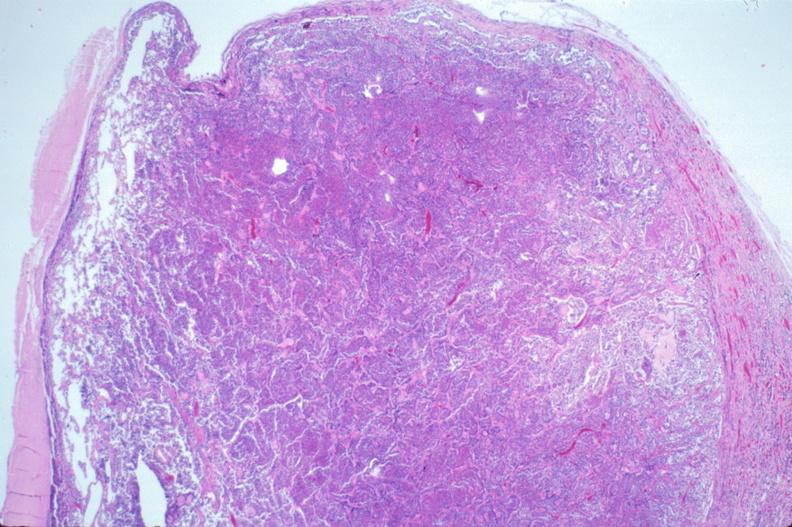does coronary artery show pituitary, chromaphobe adenoma?
Answer the question using a single word or phrase. No 